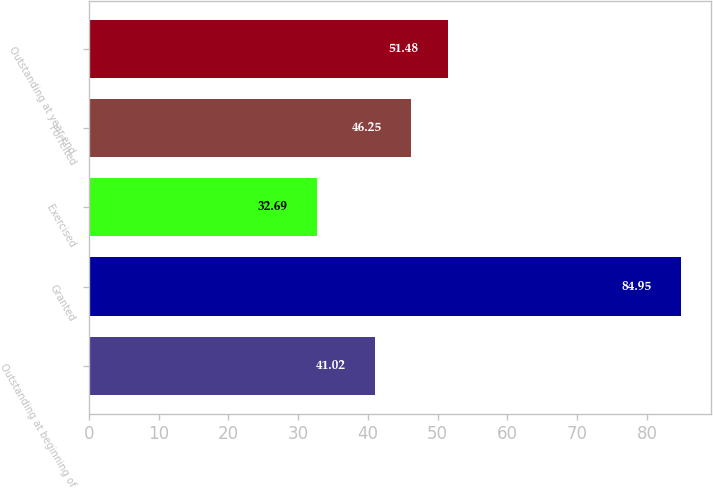Convert chart. <chart><loc_0><loc_0><loc_500><loc_500><bar_chart><fcel>Outstanding at beginning of<fcel>Granted<fcel>Exercised<fcel>Forfeited<fcel>Outstanding at year-end<nl><fcel>41.02<fcel>84.95<fcel>32.69<fcel>46.25<fcel>51.48<nl></chart> 